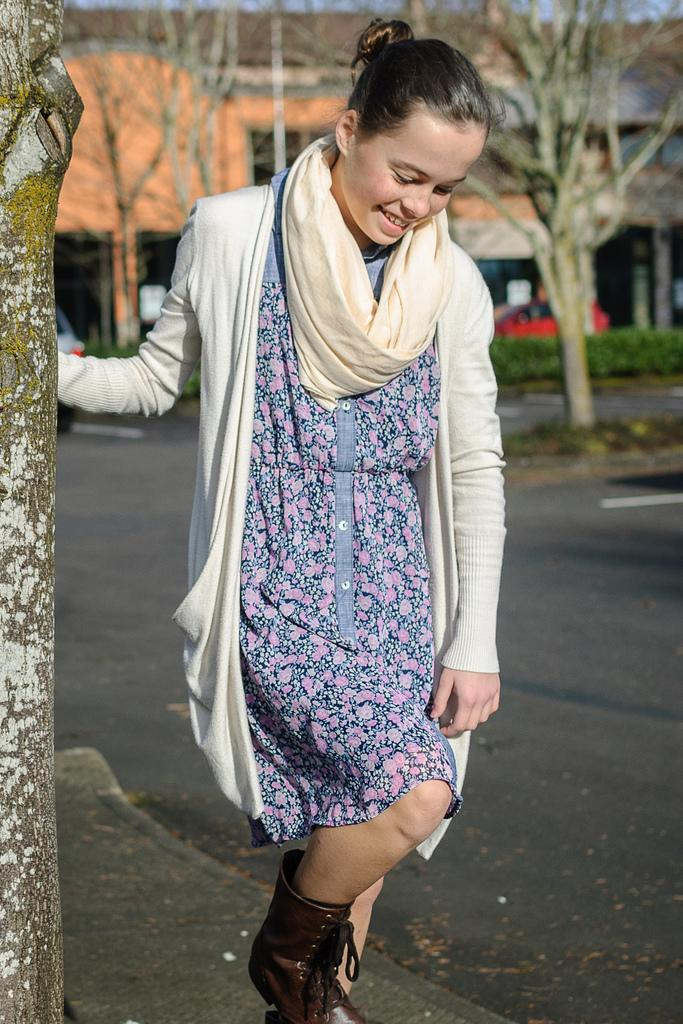Who is present in the image? There is a woman in the image. What is the woman's expression? The woman is smiling. What can be seen in the foreground of the image? There is a tree trunk in the image. What is visible in the background of the image? There is a road, trees, at least one building, vehicles, plants, and some objects in the background of the image. What type of grape is the woman holding in the image? There is no grape present in the image; the woman is not holding anything. What authority does the woman have in the image? The image does not provide any information about the woman's authority or role. 